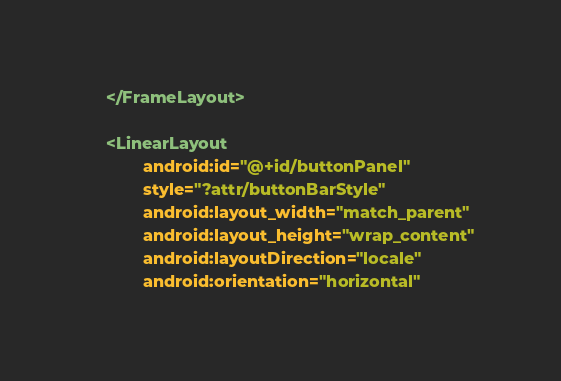<code> <loc_0><loc_0><loc_500><loc_500><_XML_>    </FrameLayout>

    <LinearLayout
            android:id="@+id/buttonPanel"
            style="?attr/buttonBarStyle"
            android:layout_width="match_parent"
            android:layout_height="wrap_content"
            android:layoutDirection="locale"
            android:orientation="horizontal"</code> 